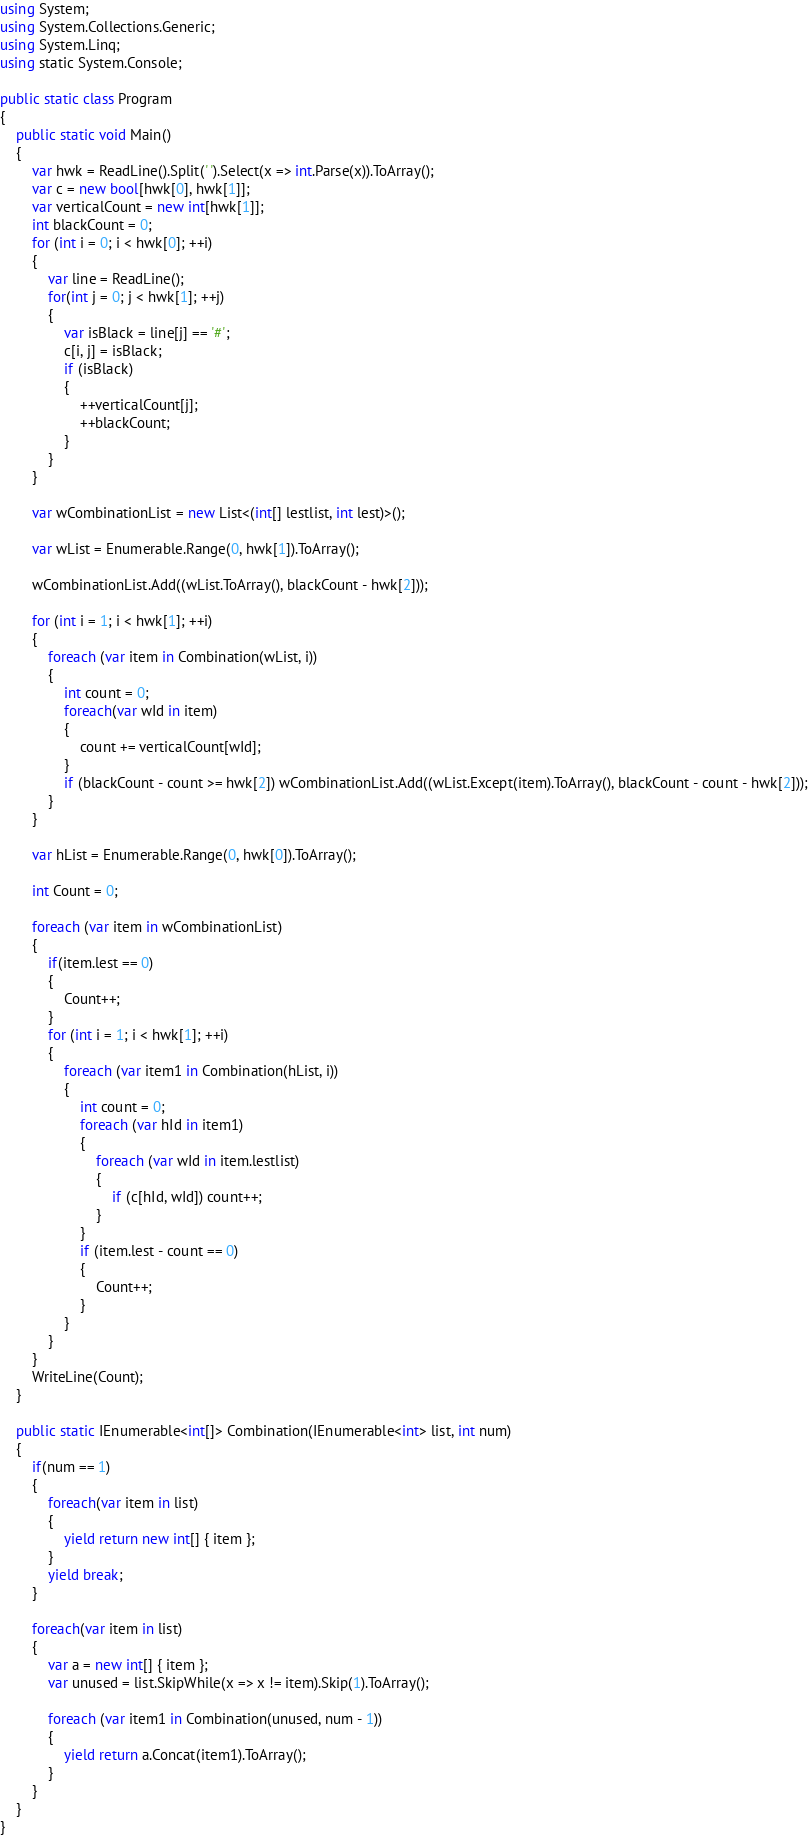Convert code to text. <code><loc_0><loc_0><loc_500><loc_500><_C#_>using System;
using System.Collections.Generic;
using System.Linq;
using static System.Console;

public static class Program
{
    public static void Main()
    {
        var hwk = ReadLine().Split(' ').Select(x => int.Parse(x)).ToArray();
        var c = new bool[hwk[0], hwk[1]];
        var verticalCount = new int[hwk[1]];
        int blackCount = 0;
        for (int i = 0; i < hwk[0]; ++i)
        {
            var line = ReadLine();
            for(int j = 0; j < hwk[1]; ++j)
            {
                var isBlack = line[j] == '#';
                c[i, j] = isBlack;
                if (isBlack)
                {
                    ++verticalCount[j];
                    ++blackCount;
                }
            }
        }

        var wCombinationList = new List<(int[] lestlist, int lest)>();

        var wList = Enumerable.Range(0, hwk[1]).ToArray();

        wCombinationList.Add((wList.ToArray(), blackCount - hwk[2]));

        for (int i = 1; i < hwk[1]; ++i)
        {
            foreach (var item in Combination(wList, i))
            {
                int count = 0;
                foreach(var wId in item)
                {
                    count += verticalCount[wId];
                }
                if (blackCount - count >= hwk[2]) wCombinationList.Add((wList.Except(item).ToArray(), blackCount - count - hwk[2]));
            }
        }

        var hList = Enumerable.Range(0, hwk[0]).ToArray();

        int Count = 0;

        foreach (var item in wCombinationList)
        {
            if(item.lest == 0)
            {
                Count++;
            }
            for (int i = 1; i < hwk[1]; ++i)
            {
                foreach (var item1 in Combination(hList, i))
                {
                    int count = 0;
                    foreach (var hId in item1)
                    {
                        foreach (var wId in item.lestlist)
                        {
                            if (c[hId, wId]) count++;
                        }
                    }
                    if (item.lest - count == 0)
                    {
                        Count++;
                    }
                }
            }
        }
        WriteLine(Count);
    }

    public static IEnumerable<int[]> Combination(IEnumerable<int> list, int num)
    {
        if(num == 1)
        {
            foreach(var item in list)
            {
                yield return new int[] { item };
            }
            yield break;
        }

        foreach(var item in list)
        {
            var a = new int[] { item };
            var unused = list.SkipWhile(x => x != item).Skip(1).ToArray();

            foreach (var item1 in Combination(unused, num - 1))
            {
                yield return a.Concat(item1).ToArray();
            }
        }
    }
}</code> 